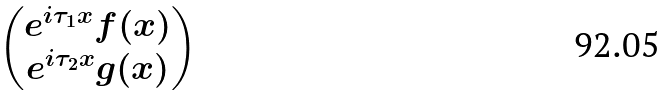Convert formula to latex. <formula><loc_0><loc_0><loc_500><loc_500>\begin{pmatrix} e ^ { i \tau _ { 1 } x } f ( x ) \\ e ^ { i \tau _ { 2 } x } g ( x ) \end{pmatrix}</formula> 